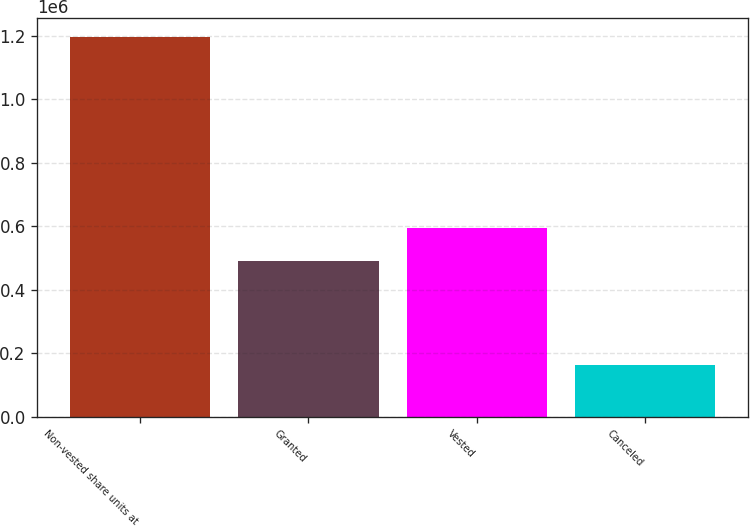Convert chart. <chart><loc_0><loc_0><loc_500><loc_500><bar_chart><fcel>Non-vested share units at<fcel>Granted<fcel>Vested<fcel>Canceled<nl><fcel>1.19644e+06<fcel>489840<fcel>593257<fcel>162266<nl></chart> 